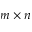<formula> <loc_0><loc_0><loc_500><loc_500>m \times n</formula> 